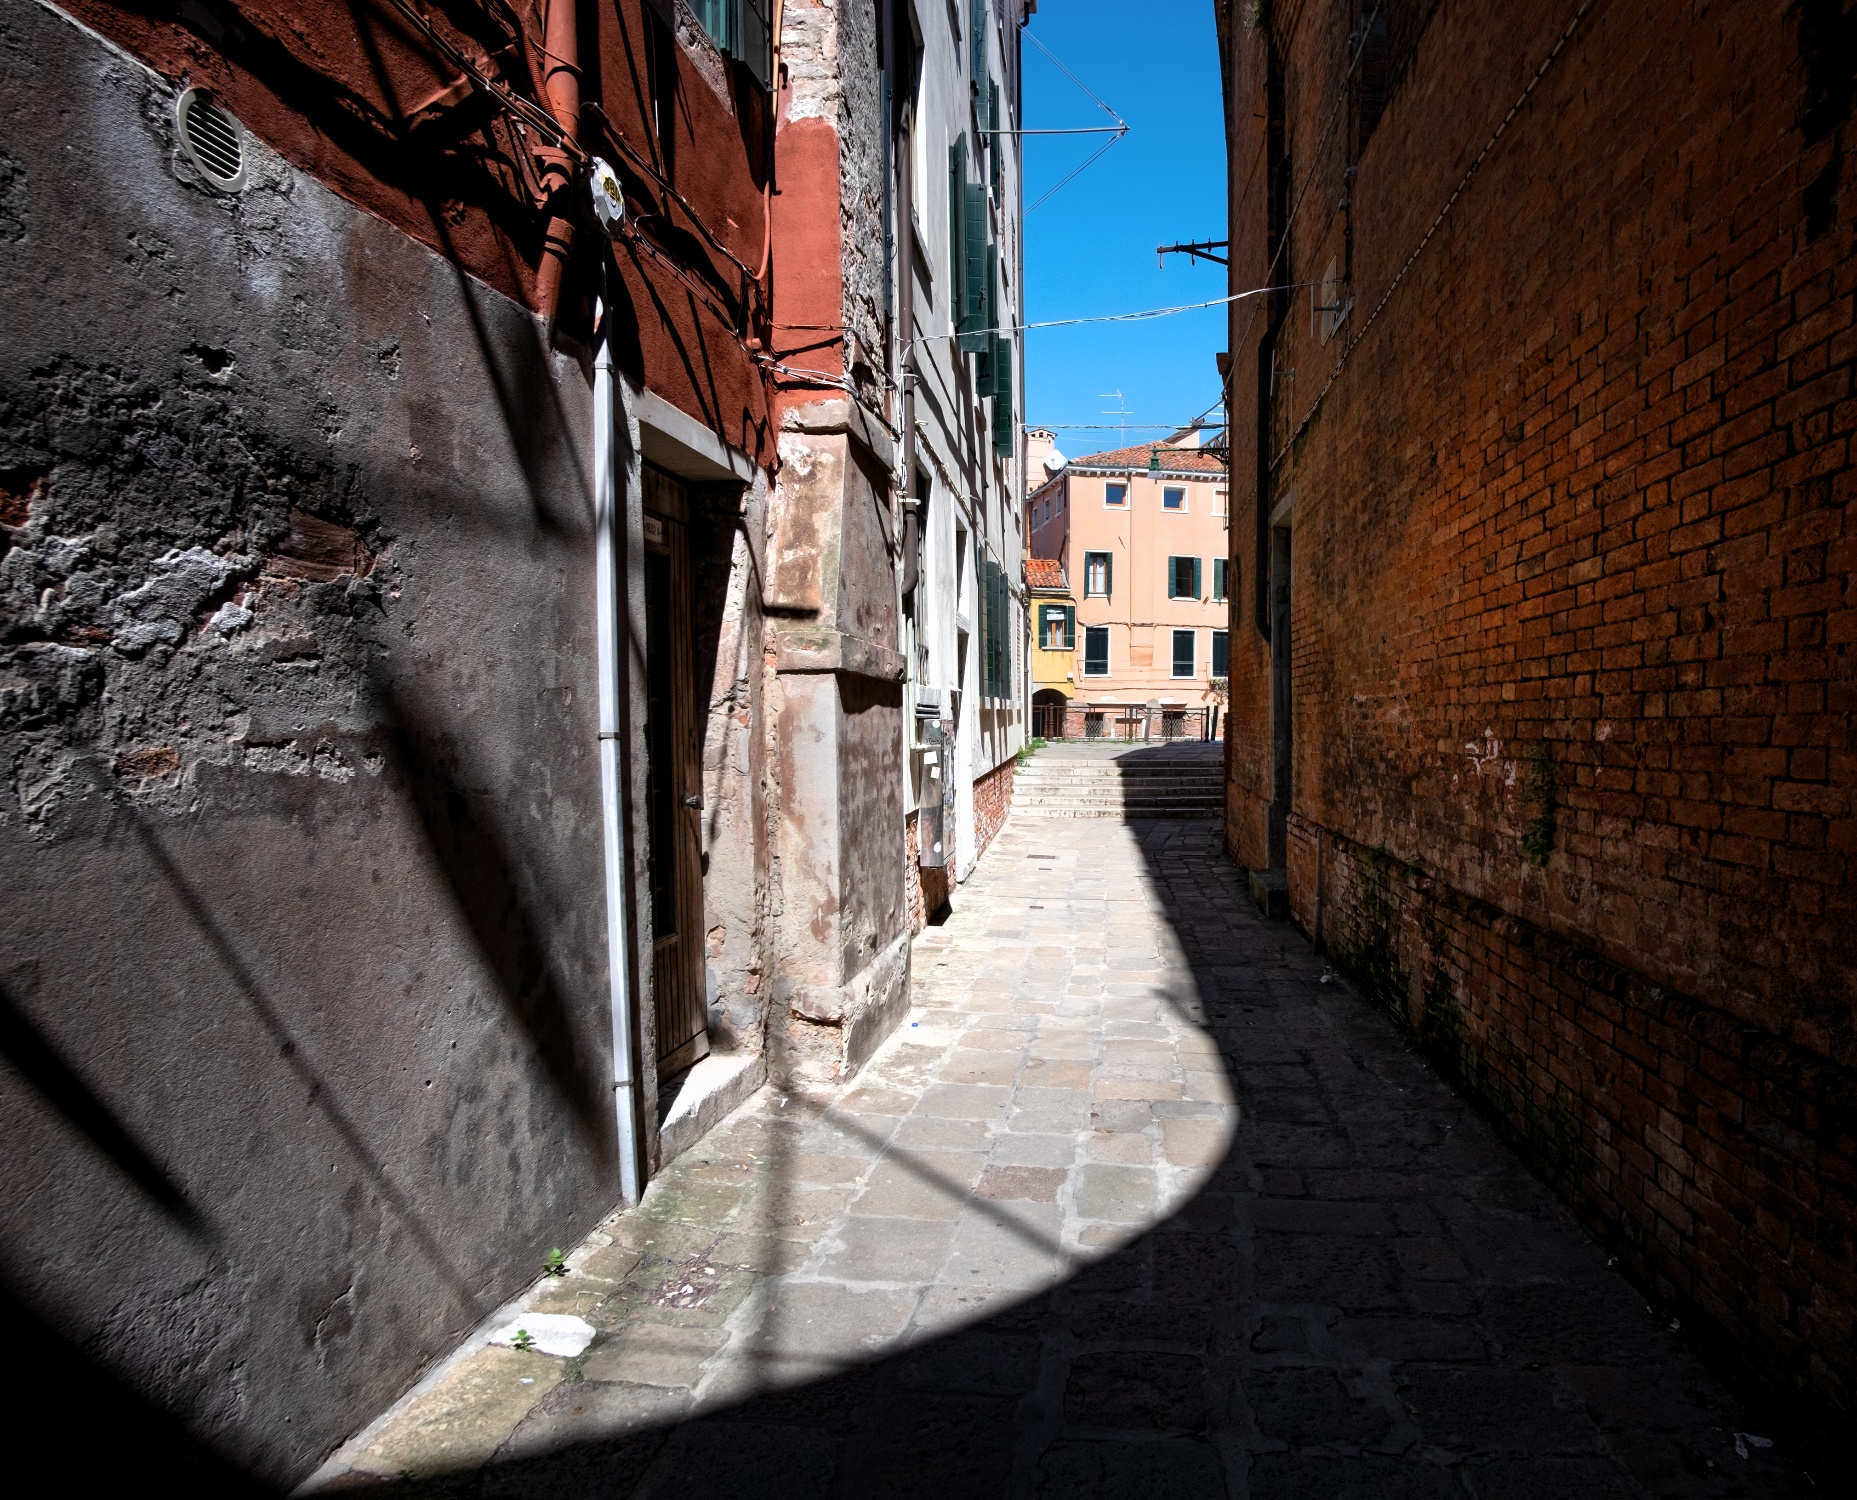If this image could speak, what would it say? 'I am an old alleyway of Venice, a silent witness to centuries of life. My cobblestones have borne the footsteps of countless souls, each leaving a subtle mark on my existence. I have seen laughter and tears, whispered secrets and shouted arguments, hurried steps and leisurely strolls. My walls, aged and weathered, are testament to the passage of time, each crack and crevice holding memories untold. The sun casts light and shadow upon me, weaving daily patterns that dance across my surface. I embrace the tranquility of dawn and the mystery of twilight. My charm lies in my history, in the stories I silently keep and in the life that continues to flow through me.' 
What could be happening in this alleyway during the peak of Carnival? During the peak of Carnival, this Venetian alleyway would transform into a vibrant and bustling hub of festivity. The cobblestones would be adorned with colorful confetti and streamers, creating a festive carpet for the revellers. The buildings, usually bathed in shadows and calm, would be alive with music and laughter. Elaborate masks and costumes would fill the alleyway, as people parade through, dancing and celebrating with an infectious energy. Street performers might turn this narrow passage into an open-air stage, playing lively music or performing acts to entertain the crowd. Lights strung between the buildings would twinkle, adding to the magical atmosphere. The entire alley would be a sensory explosion of sounds, sights, and scents, capturing the essence of Venetian Carnival in all its grandeur and delight. 
Visualize this alleyway in a futuristic Venice. What differences might there be? In a futuristic Venice, this alleyway might blend the old and the new seamlessly. The cobblestones would remain, preserving the historical charm, but perhaps they would be embedded with low-energy LEDs that light up at night, guiding nocturnal wanderers with a soft glow. The buildings, while maintaining their classic brick facade, might have smart windows that can change transparency or color based on the time of day and weather. Clotheslines might be replaced with small drones delivering packages or messages. There could be augmented reality displays seamlessly overlaid on the walls, providing historical information or virtual art exhibitions for passersby. Solar panels and green walls could be incorporated subtly into the architecture, providing energy and enhancing air quality. Despite these modern advancements, the alleyway would retain its iconic Venetian atmosphere, merging tradition with technology in a uniquely harmonious way. 